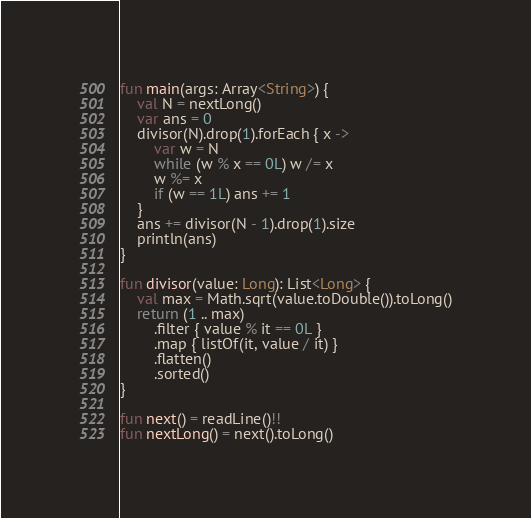Convert code to text. <code><loc_0><loc_0><loc_500><loc_500><_Kotlin_>fun main(args: Array<String>) {
    val N = nextLong()
    var ans = 0
    divisor(N).drop(1).forEach { x ->
        var w = N
        while (w % x == 0L) w /= x
        w %= x
        if (w == 1L) ans += 1
    }
    ans += divisor(N - 1).drop(1).size
    println(ans)
}

fun divisor(value: Long): List<Long> {
    val max = Math.sqrt(value.toDouble()).toLong()
    return (1 .. max)
        .filter { value % it == 0L }
        .map { listOf(it, value / it) }
        .flatten()
        .sorted()
}

fun next() = readLine()!!
fun nextLong() = next().toLong()

</code> 